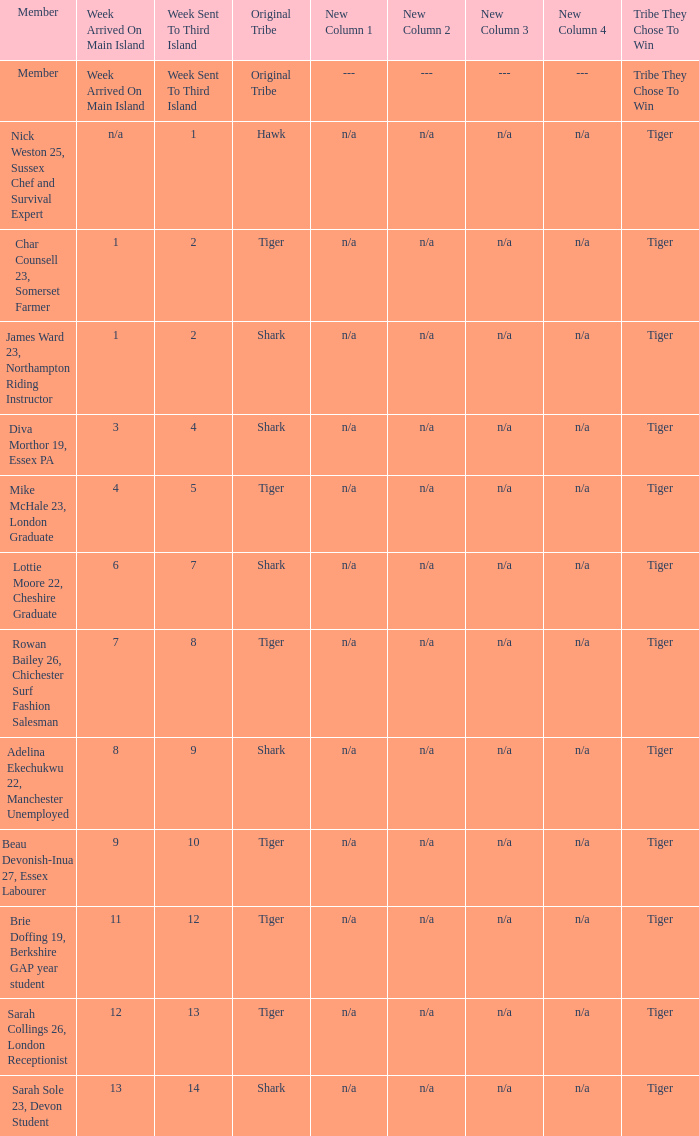What week did the member who's original tribe was shark and who was sent to the third island on week 14 arrive on the main island? 13.0. 